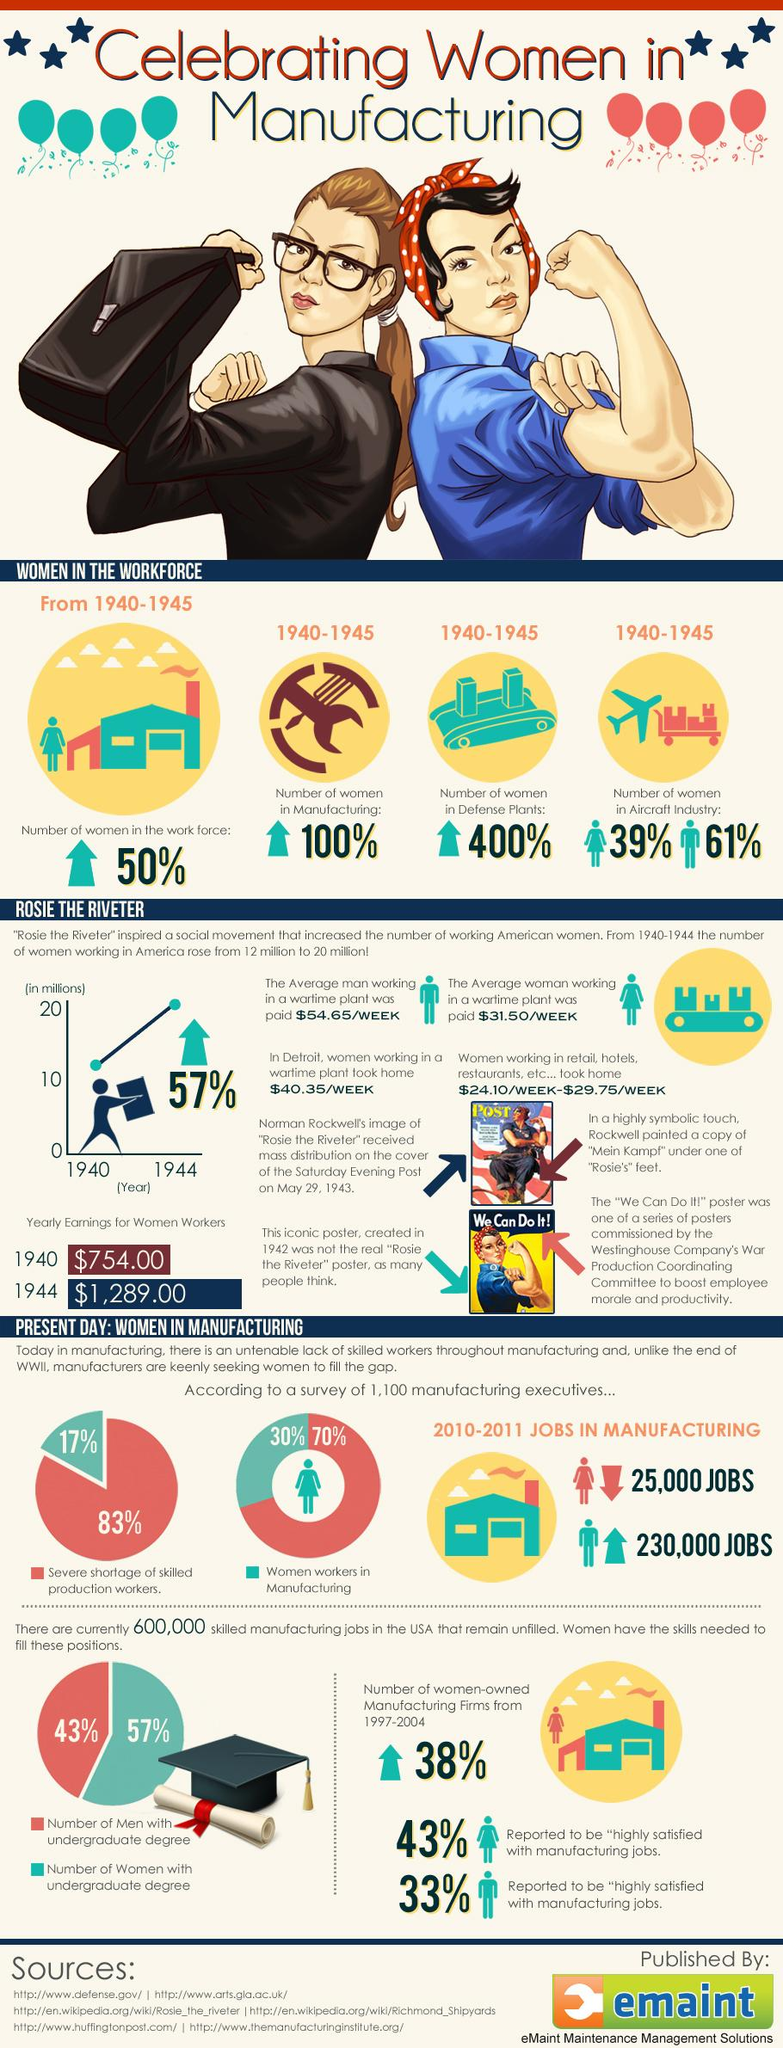Identify some key points in this picture. The majority gender in the aircraft industry is men. During the years 1940-1945, the gender gap in the aircraft industry was estimated to be 22%. According to the pie chart, 57% of women held undergraduate degrees. Six sources are listed at the bottom. From 1940 to 1944, the yearly earnings of women workers increased by $535.00. 